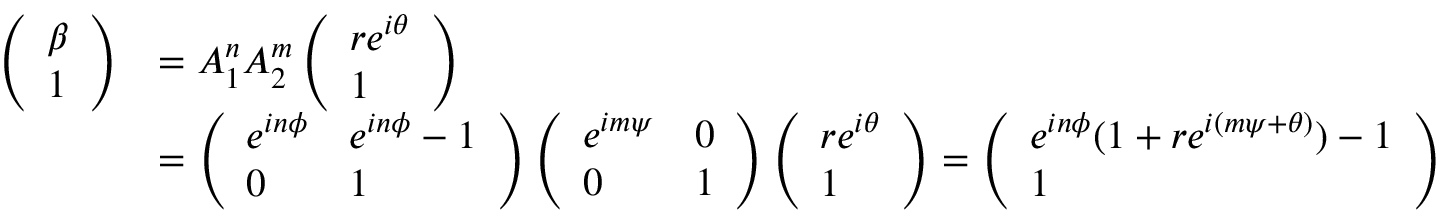Convert formula to latex. <formula><loc_0><loc_0><loc_500><loc_500>\begin{array} { r l } { \left ( \begin{array} { l } { \beta } \\ { 1 } \end{array} \right ) } & { = A _ { 1 } ^ { n } A _ { 2 } ^ { m } \left ( \begin{array} { l } { r e ^ { i \theta } } \\ { 1 } \end{array} \right ) } \\ & { = \left ( \begin{array} { l l } { e ^ { i n \phi } } & { e ^ { i n \phi } - 1 } \\ { 0 } & { 1 } \end{array} \right ) \left ( \begin{array} { l l } { e ^ { i m \psi } } & { 0 } \\ { 0 } & { 1 } \end{array} \right ) \left ( \begin{array} { l } { r e ^ { i \theta } } \\ { 1 } \end{array} \right ) = \left ( \begin{array} { l } { e ^ { i n \phi } ( 1 + r e ^ { i ( m \psi + \theta ) } ) - 1 } \\ { 1 } \end{array} \right ) } \end{array}</formula> 